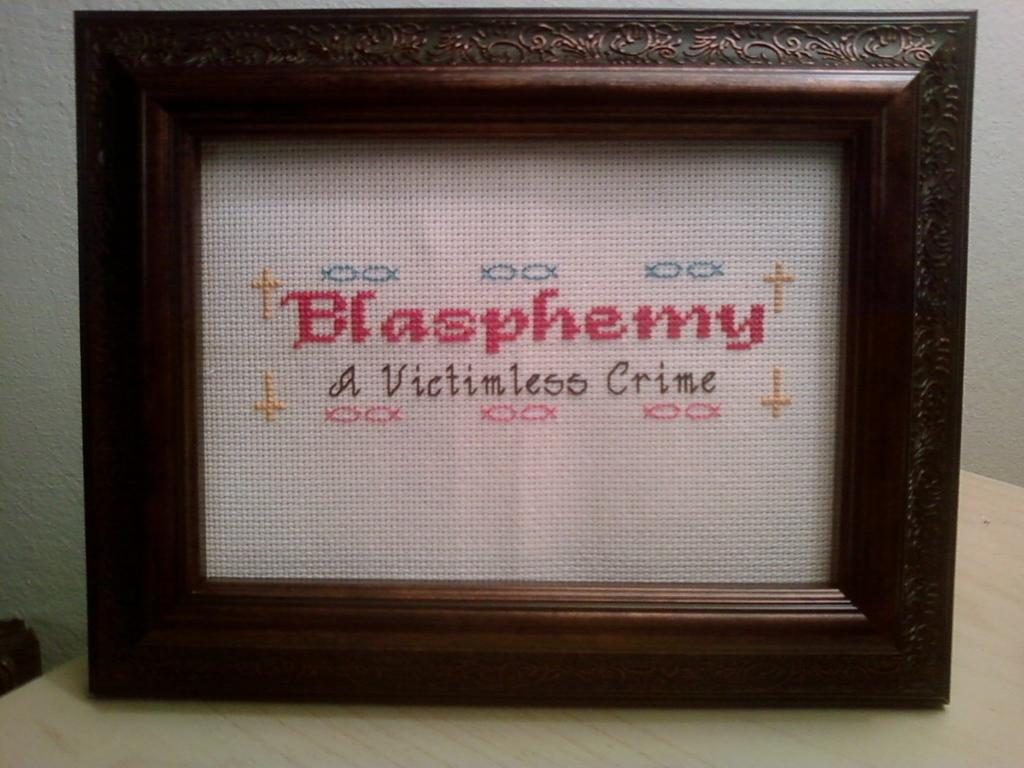<image>
Describe the image concisely. A cross-stitched work of art that says, Blasphemy A Victimless Crime that is framed. 